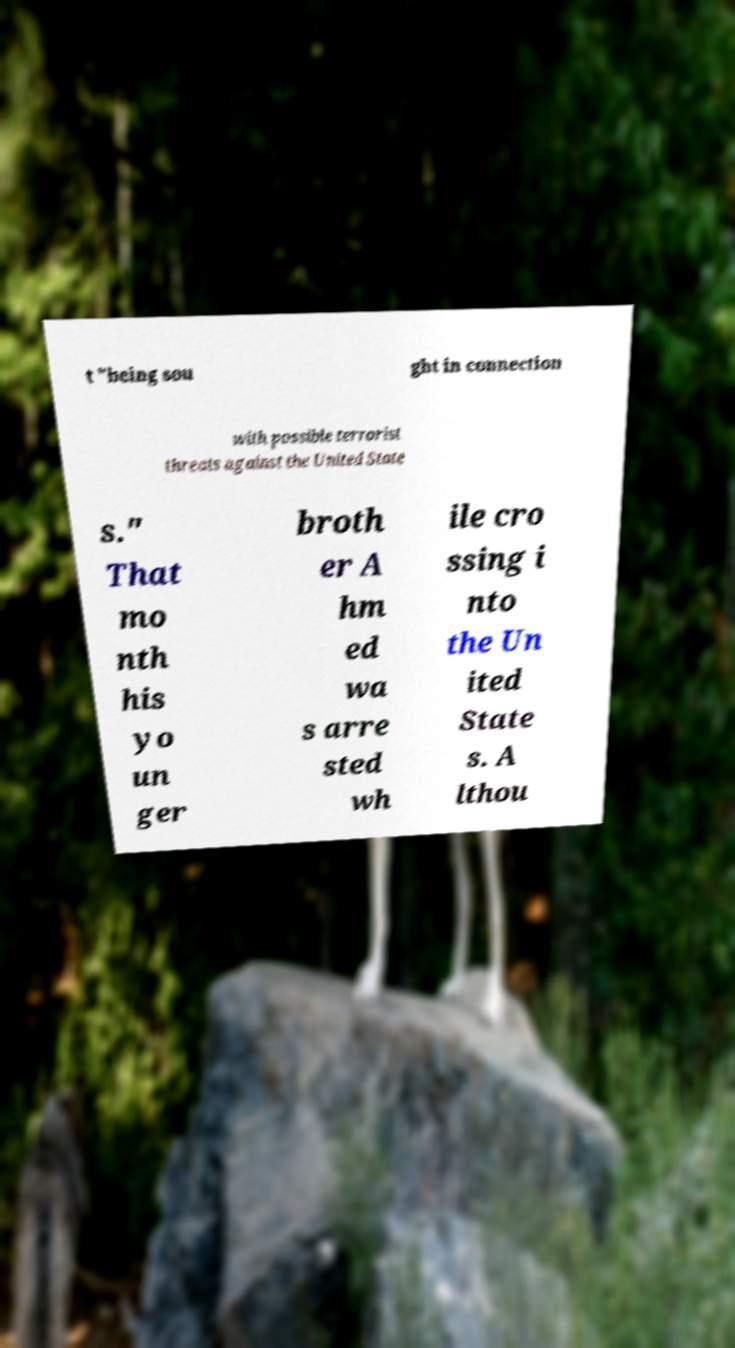Can you accurately transcribe the text from the provided image for me? t "being sou ght in connection with possible terrorist threats against the United State s." That mo nth his yo un ger broth er A hm ed wa s arre sted wh ile cro ssing i nto the Un ited State s. A lthou 